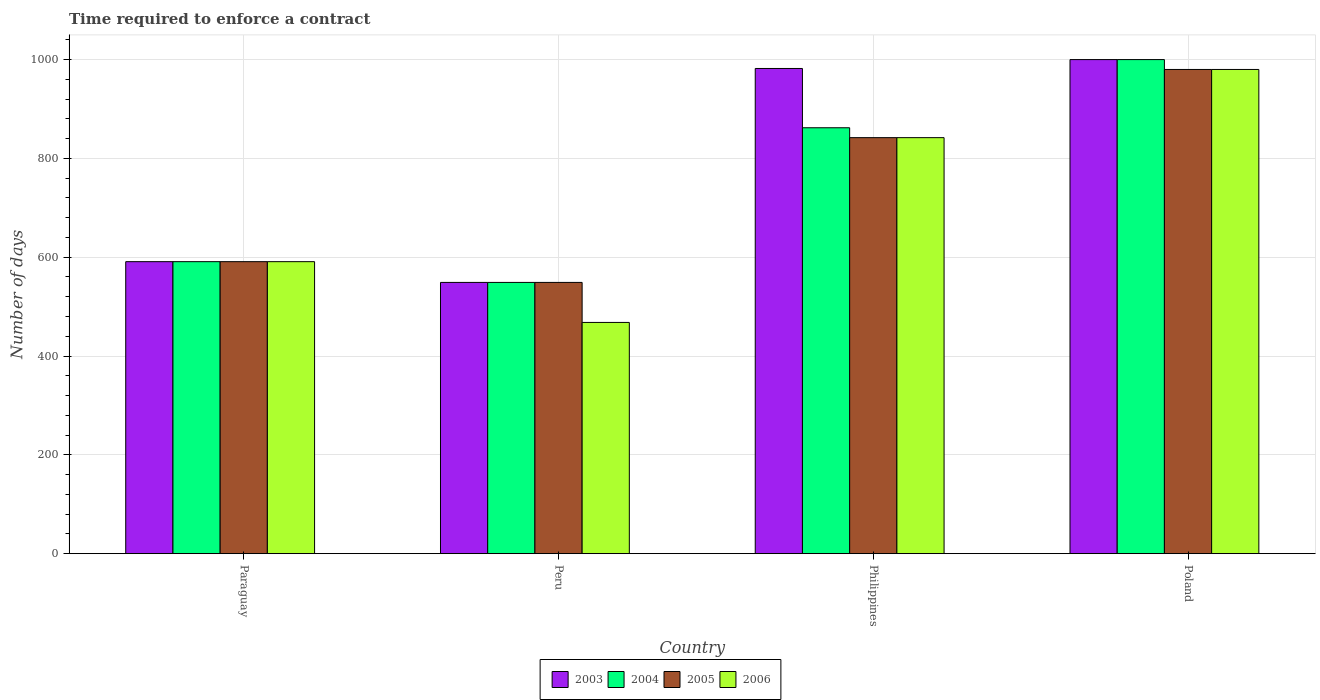Are the number of bars per tick equal to the number of legend labels?
Your answer should be compact. Yes. What is the label of the 4th group of bars from the left?
Provide a succinct answer. Poland. What is the number of days required to enforce a contract in 2005 in Philippines?
Keep it short and to the point. 842. Across all countries, what is the maximum number of days required to enforce a contract in 2005?
Offer a very short reply. 980. Across all countries, what is the minimum number of days required to enforce a contract in 2005?
Your answer should be very brief. 549. In which country was the number of days required to enforce a contract in 2006 minimum?
Provide a succinct answer. Peru. What is the total number of days required to enforce a contract in 2003 in the graph?
Offer a terse response. 3122. What is the difference between the number of days required to enforce a contract in 2006 in Paraguay and that in Philippines?
Your answer should be compact. -251. What is the difference between the number of days required to enforce a contract in 2004 in Philippines and the number of days required to enforce a contract in 2005 in Paraguay?
Offer a very short reply. 271. What is the average number of days required to enforce a contract in 2003 per country?
Your response must be concise. 780.5. What is the difference between the number of days required to enforce a contract of/in 2004 and number of days required to enforce a contract of/in 2003 in Philippines?
Your answer should be compact. -120. In how many countries, is the number of days required to enforce a contract in 2005 greater than 80 days?
Provide a succinct answer. 4. What is the ratio of the number of days required to enforce a contract in 2006 in Peru to that in Philippines?
Make the answer very short. 0.56. Is the number of days required to enforce a contract in 2005 in Peru less than that in Philippines?
Your response must be concise. Yes. Is the difference between the number of days required to enforce a contract in 2004 in Philippines and Poland greater than the difference between the number of days required to enforce a contract in 2003 in Philippines and Poland?
Offer a very short reply. No. What is the difference between the highest and the second highest number of days required to enforce a contract in 2004?
Your response must be concise. 138. What is the difference between the highest and the lowest number of days required to enforce a contract in 2004?
Your answer should be very brief. 451. In how many countries, is the number of days required to enforce a contract in 2006 greater than the average number of days required to enforce a contract in 2006 taken over all countries?
Your answer should be compact. 2. Is it the case that in every country, the sum of the number of days required to enforce a contract in 2003 and number of days required to enforce a contract in 2005 is greater than the sum of number of days required to enforce a contract in 2004 and number of days required to enforce a contract in 2006?
Offer a very short reply. No. What does the 4th bar from the left in Peru represents?
Give a very brief answer. 2006. How many countries are there in the graph?
Your answer should be very brief. 4. Does the graph contain grids?
Offer a very short reply. Yes. Where does the legend appear in the graph?
Keep it short and to the point. Bottom center. How many legend labels are there?
Offer a terse response. 4. What is the title of the graph?
Your answer should be compact. Time required to enforce a contract. What is the label or title of the X-axis?
Provide a short and direct response. Country. What is the label or title of the Y-axis?
Provide a short and direct response. Number of days. What is the Number of days of 2003 in Paraguay?
Make the answer very short. 591. What is the Number of days of 2004 in Paraguay?
Provide a short and direct response. 591. What is the Number of days of 2005 in Paraguay?
Your answer should be compact. 591. What is the Number of days of 2006 in Paraguay?
Keep it short and to the point. 591. What is the Number of days in 2003 in Peru?
Your answer should be very brief. 549. What is the Number of days of 2004 in Peru?
Make the answer very short. 549. What is the Number of days of 2005 in Peru?
Keep it short and to the point. 549. What is the Number of days of 2006 in Peru?
Your answer should be compact. 468. What is the Number of days of 2003 in Philippines?
Offer a very short reply. 982. What is the Number of days in 2004 in Philippines?
Your answer should be very brief. 862. What is the Number of days of 2005 in Philippines?
Make the answer very short. 842. What is the Number of days in 2006 in Philippines?
Give a very brief answer. 842. What is the Number of days in 2004 in Poland?
Keep it short and to the point. 1000. What is the Number of days of 2005 in Poland?
Make the answer very short. 980. What is the Number of days of 2006 in Poland?
Make the answer very short. 980. Across all countries, what is the maximum Number of days of 2004?
Ensure brevity in your answer.  1000. Across all countries, what is the maximum Number of days in 2005?
Offer a terse response. 980. Across all countries, what is the maximum Number of days in 2006?
Ensure brevity in your answer.  980. Across all countries, what is the minimum Number of days of 2003?
Your answer should be very brief. 549. Across all countries, what is the minimum Number of days of 2004?
Offer a very short reply. 549. Across all countries, what is the minimum Number of days of 2005?
Make the answer very short. 549. Across all countries, what is the minimum Number of days of 2006?
Your answer should be compact. 468. What is the total Number of days in 2003 in the graph?
Provide a short and direct response. 3122. What is the total Number of days in 2004 in the graph?
Offer a terse response. 3002. What is the total Number of days of 2005 in the graph?
Your answer should be compact. 2962. What is the total Number of days of 2006 in the graph?
Your answer should be compact. 2881. What is the difference between the Number of days of 2003 in Paraguay and that in Peru?
Provide a succinct answer. 42. What is the difference between the Number of days in 2006 in Paraguay and that in Peru?
Make the answer very short. 123. What is the difference between the Number of days in 2003 in Paraguay and that in Philippines?
Your answer should be very brief. -391. What is the difference between the Number of days of 2004 in Paraguay and that in Philippines?
Ensure brevity in your answer.  -271. What is the difference between the Number of days in 2005 in Paraguay and that in Philippines?
Ensure brevity in your answer.  -251. What is the difference between the Number of days of 2006 in Paraguay and that in Philippines?
Make the answer very short. -251. What is the difference between the Number of days in 2003 in Paraguay and that in Poland?
Offer a terse response. -409. What is the difference between the Number of days of 2004 in Paraguay and that in Poland?
Offer a terse response. -409. What is the difference between the Number of days of 2005 in Paraguay and that in Poland?
Your answer should be compact. -389. What is the difference between the Number of days in 2006 in Paraguay and that in Poland?
Give a very brief answer. -389. What is the difference between the Number of days in 2003 in Peru and that in Philippines?
Your response must be concise. -433. What is the difference between the Number of days in 2004 in Peru and that in Philippines?
Your response must be concise. -313. What is the difference between the Number of days of 2005 in Peru and that in Philippines?
Make the answer very short. -293. What is the difference between the Number of days of 2006 in Peru and that in Philippines?
Offer a terse response. -374. What is the difference between the Number of days of 2003 in Peru and that in Poland?
Offer a very short reply. -451. What is the difference between the Number of days in 2004 in Peru and that in Poland?
Your answer should be compact. -451. What is the difference between the Number of days in 2005 in Peru and that in Poland?
Your response must be concise. -431. What is the difference between the Number of days in 2006 in Peru and that in Poland?
Offer a terse response. -512. What is the difference between the Number of days in 2003 in Philippines and that in Poland?
Your answer should be very brief. -18. What is the difference between the Number of days of 2004 in Philippines and that in Poland?
Ensure brevity in your answer.  -138. What is the difference between the Number of days in 2005 in Philippines and that in Poland?
Your answer should be compact. -138. What is the difference between the Number of days of 2006 in Philippines and that in Poland?
Your answer should be very brief. -138. What is the difference between the Number of days in 2003 in Paraguay and the Number of days in 2004 in Peru?
Give a very brief answer. 42. What is the difference between the Number of days in 2003 in Paraguay and the Number of days in 2006 in Peru?
Your response must be concise. 123. What is the difference between the Number of days in 2004 in Paraguay and the Number of days in 2006 in Peru?
Provide a short and direct response. 123. What is the difference between the Number of days of 2005 in Paraguay and the Number of days of 2006 in Peru?
Give a very brief answer. 123. What is the difference between the Number of days of 2003 in Paraguay and the Number of days of 2004 in Philippines?
Give a very brief answer. -271. What is the difference between the Number of days in 2003 in Paraguay and the Number of days in 2005 in Philippines?
Your response must be concise. -251. What is the difference between the Number of days in 2003 in Paraguay and the Number of days in 2006 in Philippines?
Ensure brevity in your answer.  -251. What is the difference between the Number of days in 2004 in Paraguay and the Number of days in 2005 in Philippines?
Your answer should be compact. -251. What is the difference between the Number of days of 2004 in Paraguay and the Number of days of 2006 in Philippines?
Ensure brevity in your answer.  -251. What is the difference between the Number of days in 2005 in Paraguay and the Number of days in 2006 in Philippines?
Give a very brief answer. -251. What is the difference between the Number of days of 2003 in Paraguay and the Number of days of 2004 in Poland?
Provide a short and direct response. -409. What is the difference between the Number of days of 2003 in Paraguay and the Number of days of 2005 in Poland?
Offer a terse response. -389. What is the difference between the Number of days in 2003 in Paraguay and the Number of days in 2006 in Poland?
Your answer should be very brief. -389. What is the difference between the Number of days in 2004 in Paraguay and the Number of days in 2005 in Poland?
Make the answer very short. -389. What is the difference between the Number of days in 2004 in Paraguay and the Number of days in 2006 in Poland?
Give a very brief answer. -389. What is the difference between the Number of days of 2005 in Paraguay and the Number of days of 2006 in Poland?
Offer a terse response. -389. What is the difference between the Number of days of 2003 in Peru and the Number of days of 2004 in Philippines?
Offer a very short reply. -313. What is the difference between the Number of days in 2003 in Peru and the Number of days in 2005 in Philippines?
Keep it short and to the point. -293. What is the difference between the Number of days in 2003 in Peru and the Number of days in 2006 in Philippines?
Give a very brief answer. -293. What is the difference between the Number of days in 2004 in Peru and the Number of days in 2005 in Philippines?
Provide a short and direct response. -293. What is the difference between the Number of days in 2004 in Peru and the Number of days in 2006 in Philippines?
Your response must be concise. -293. What is the difference between the Number of days in 2005 in Peru and the Number of days in 2006 in Philippines?
Provide a short and direct response. -293. What is the difference between the Number of days of 2003 in Peru and the Number of days of 2004 in Poland?
Offer a terse response. -451. What is the difference between the Number of days of 2003 in Peru and the Number of days of 2005 in Poland?
Offer a very short reply. -431. What is the difference between the Number of days in 2003 in Peru and the Number of days in 2006 in Poland?
Make the answer very short. -431. What is the difference between the Number of days of 2004 in Peru and the Number of days of 2005 in Poland?
Provide a succinct answer. -431. What is the difference between the Number of days in 2004 in Peru and the Number of days in 2006 in Poland?
Make the answer very short. -431. What is the difference between the Number of days of 2005 in Peru and the Number of days of 2006 in Poland?
Offer a terse response. -431. What is the difference between the Number of days in 2004 in Philippines and the Number of days in 2005 in Poland?
Your answer should be compact. -118. What is the difference between the Number of days of 2004 in Philippines and the Number of days of 2006 in Poland?
Offer a terse response. -118. What is the difference between the Number of days in 2005 in Philippines and the Number of days in 2006 in Poland?
Offer a terse response. -138. What is the average Number of days of 2003 per country?
Make the answer very short. 780.5. What is the average Number of days of 2004 per country?
Keep it short and to the point. 750.5. What is the average Number of days of 2005 per country?
Keep it short and to the point. 740.5. What is the average Number of days of 2006 per country?
Offer a very short reply. 720.25. What is the difference between the Number of days of 2003 and Number of days of 2006 in Peru?
Give a very brief answer. 81. What is the difference between the Number of days in 2004 and Number of days in 2005 in Peru?
Provide a short and direct response. 0. What is the difference between the Number of days in 2004 and Number of days in 2006 in Peru?
Offer a very short reply. 81. What is the difference between the Number of days of 2005 and Number of days of 2006 in Peru?
Provide a succinct answer. 81. What is the difference between the Number of days of 2003 and Number of days of 2004 in Philippines?
Provide a short and direct response. 120. What is the difference between the Number of days of 2003 and Number of days of 2005 in Philippines?
Provide a short and direct response. 140. What is the difference between the Number of days in 2003 and Number of days in 2006 in Philippines?
Offer a very short reply. 140. What is the difference between the Number of days of 2004 and Number of days of 2005 in Philippines?
Ensure brevity in your answer.  20. What is the difference between the Number of days of 2005 and Number of days of 2006 in Philippines?
Ensure brevity in your answer.  0. What is the difference between the Number of days in 2003 and Number of days in 2004 in Poland?
Your response must be concise. 0. What is the difference between the Number of days in 2003 and Number of days in 2005 in Poland?
Your answer should be very brief. 20. What is the difference between the Number of days in 2003 and Number of days in 2006 in Poland?
Your answer should be compact. 20. What is the difference between the Number of days of 2004 and Number of days of 2006 in Poland?
Offer a very short reply. 20. What is the ratio of the Number of days of 2003 in Paraguay to that in Peru?
Ensure brevity in your answer.  1.08. What is the ratio of the Number of days of 2004 in Paraguay to that in Peru?
Offer a very short reply. 1.08. What is the ratio of the Number of days in 2005 in Paraguay to that in Peru?
Your response must be concise. 1.08. What is the ratio of the Number of days in 2006 in Paraguay to that in Peru?
Offer a terse response. 1.26. What is the ratio of the Number of days of 2003 in Paraguay to that in Philippines?
Make the answer very short. 0.6. What is the ratio of the Number of days in 2004 in Paraguay to that in Philippines?
Make the answer very short. 0.69. What is the ratio of the Number of days of 2005 in Paraguay to that in Philippines?
Your answer should be very brief. 0.7. What is the ratio of the Number of days of 2006 in Paraguay to that in Philippines?
Give a very brief answer. 0.7. What is the ratio of the Number of days in 2003 in Paraguay to that in Poland?
Your answer should be very brief. 0.59. What is the ratio of the Number of days in 2004 in Paraguay to that in Poland?
Ensure brevity in your answer.  0.59. What is the ratio of the Number of days in 2005 in Paraguay to that in Poland?
Your response must be concise. 0.6. What is the ratio of the Number of days of 2006 in Paraguay to that in Poland?
Your answer should be very brief. 0.6. What is the ratio of the Number of days of 2003 in Peru to that in Philippines?
Ensure brevity in your answer.  0.56. What is the ratio of the Number of days of 2004 in Peru to that in Philippines?
Make the answer very short. 0.64. What is the ratio of the Number of days of 2005 in Peru to that in Philippines?
Ensure brevity in your answer.  0.65. What is the ratio of the Number of days of 2006 in Peru to that in Philippines?
Your response must be concise. 0.56. What is the ratio of the Number of days of 2003 in Peru to that in Poland?
Ensure brevity in your answer.  0.55. What is the ratio of the Number of days in 2004 in Peru to that in Poland?
Provide a short and direct response. 0.55. What is the ratio of the Number of days of 2005 in Peru to that in Poland?
Your answer should be compact. 0.56. What is the ratio of the Number of days of 2006 in Peru to that in Poland?
Give a very brief answer. 0.48. What is the ratio of the Number of days of 2003 in Philippines to that in Poland?
Ensure brevity in your answer.  0.98. What is the ratio of the Number of days of 2004 in Philippines to that in Poland?
Provide a short and direct response. 0.86. What is the ratio of the Number of days of 2005 in Philippines to that in Poland?
Give a very brief answer. 0.86. What is the ratio of the Number of days in 2006 in Philippines to that in Poland?
Provide a succinct answer. 0.86. What is the difference between the highest and the second highest Number of days of 2004?
Your answer should be very brief. 138. What is the difference between the highest and the second highest Number of days of 2005?
Make the answer very short. 138. What is the difference between the highest and the second highest Number of days of 2006?
Provide a short and direct response. 138. What is the difference between the highest and the lowest Number of days of 2003?
Make the answer very short. 451. What is the difference between the highest and the lowest Number of days of 2004?
Your response must be concise. 451. What is the difference between the highest and the lowest Number of days of 2005?
Provide a short and direct response. 431. What is the difference between the highest and the lowest Number of days of 2006?
Provide a succinct answer. 512. 